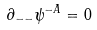<formula> <loc_0><loc_0><loc_500><loc_500>\partial _ { - - } \psi ^ { - A } = 0</formula> 